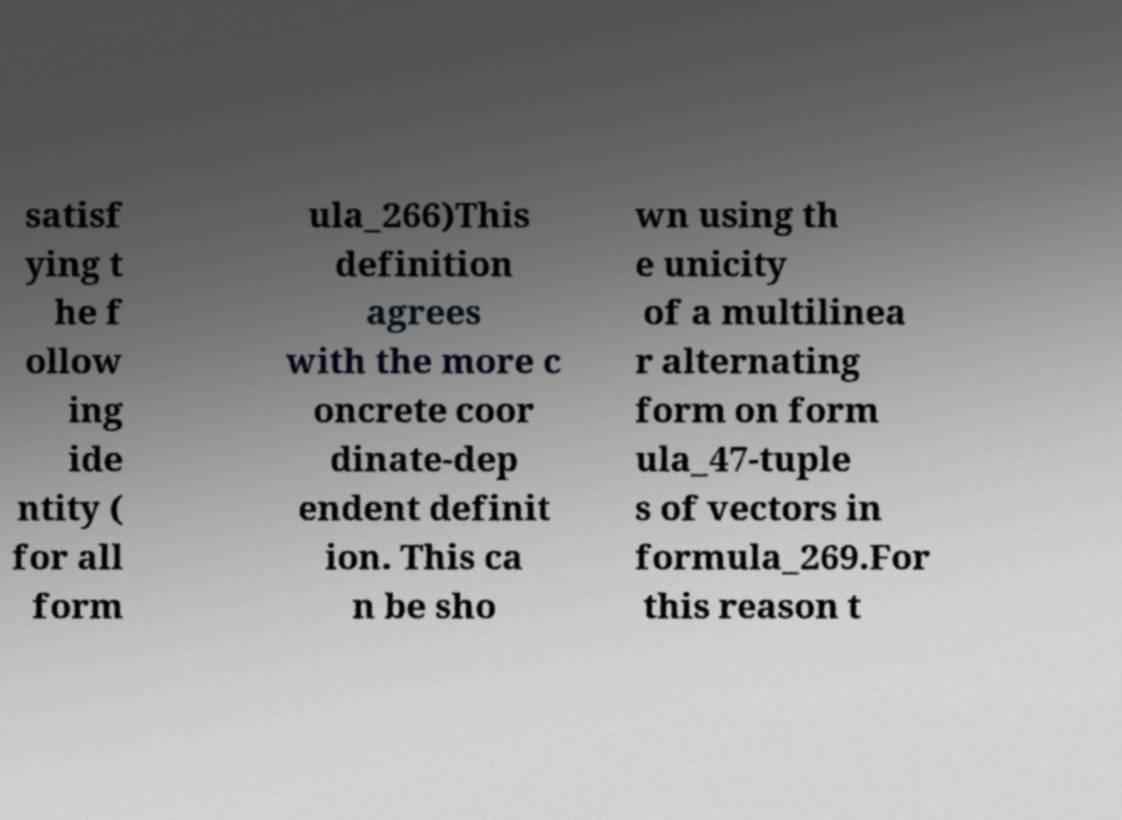Could you assist in decoding the text presented in this image and type it out clearly? satisf ying t he f ollow ing ide ntity ( for all form ula_266)This definition agrees with the more c oncrete coor dinate-dep endent definit ion. This ca n be sho wn using th e unicity of a multilinea r alternating form on form ula_47-tuple s of vectors in formula_269.For this reason t 